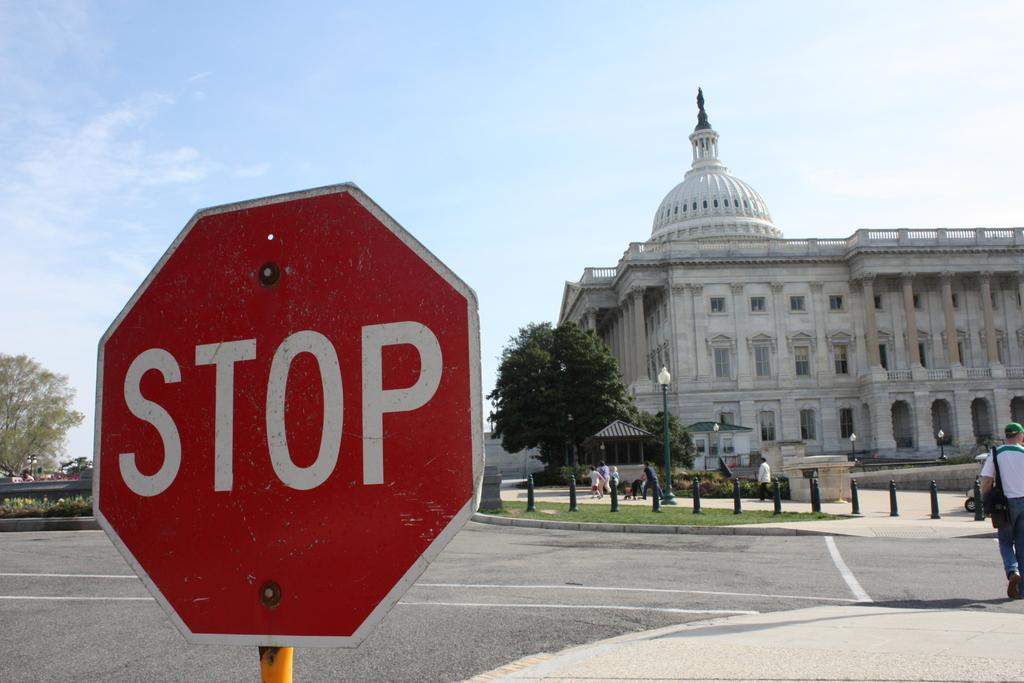Provide a one-sentence caption for the provided image. A stop sign with the United States Capitol building in the background. 